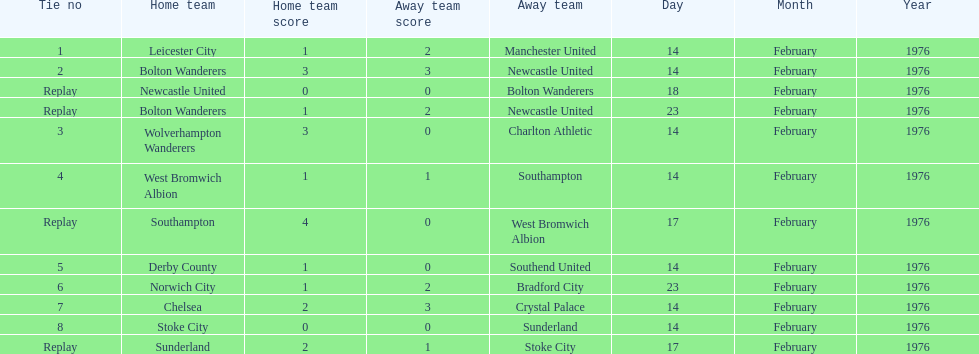Which teams played the same day as leicester city and manchester united? Bolton Wanderers, Newcastle United. 